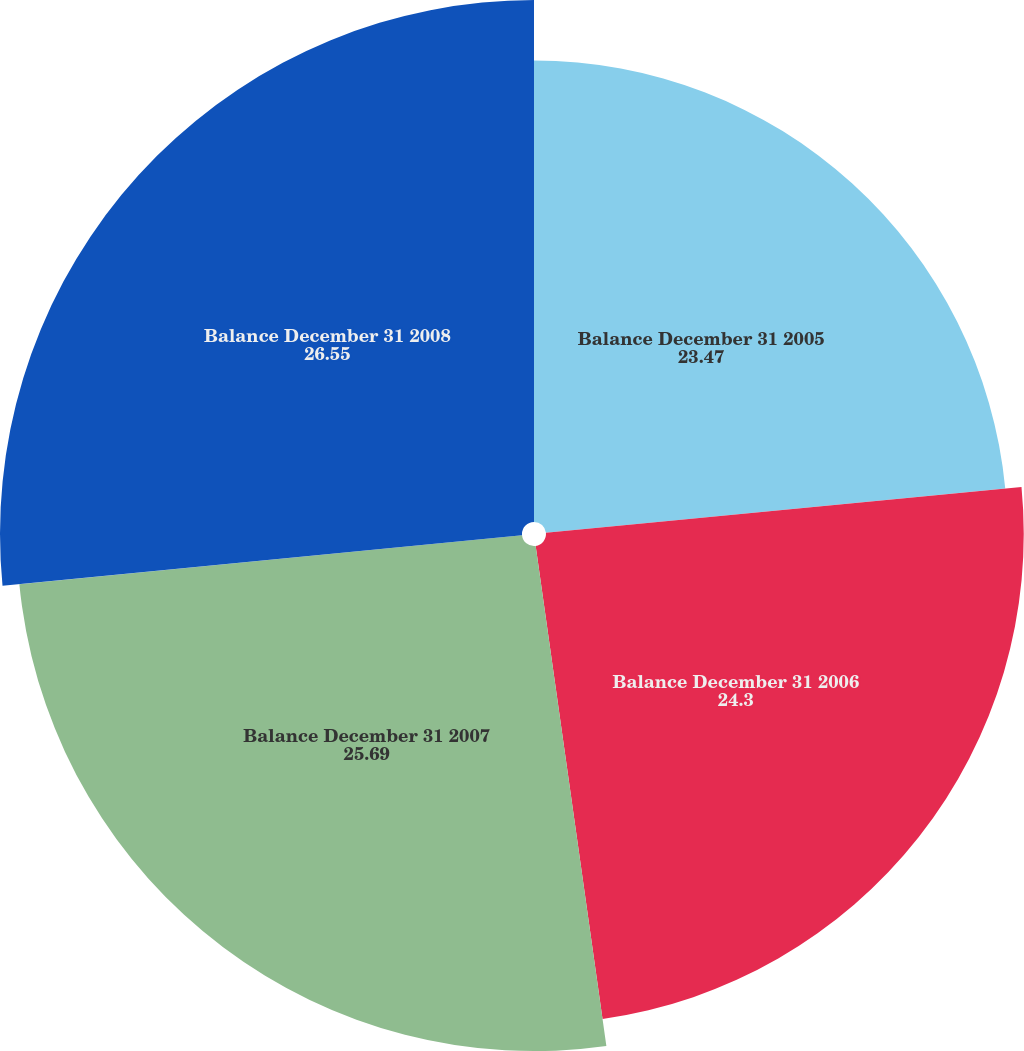Convert chart. <chart><loc_0><loc_0><loc_500><loc_500><pie_chart><fcel>Balance December 31 2005<fcel>Balance December 31 2006<fcel>Balance December 31 2007<fcel>Balance December 31 2008<nl><fcel>23.47%<fcel>24.3%<fcel>25.69%<fcel>26.55%<nl></chart> 